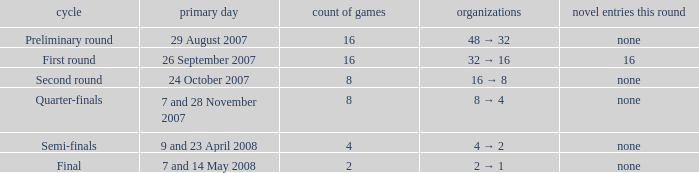What is the sum of Number of fixtures when the rounds shows quarter-finals? 8.0. 